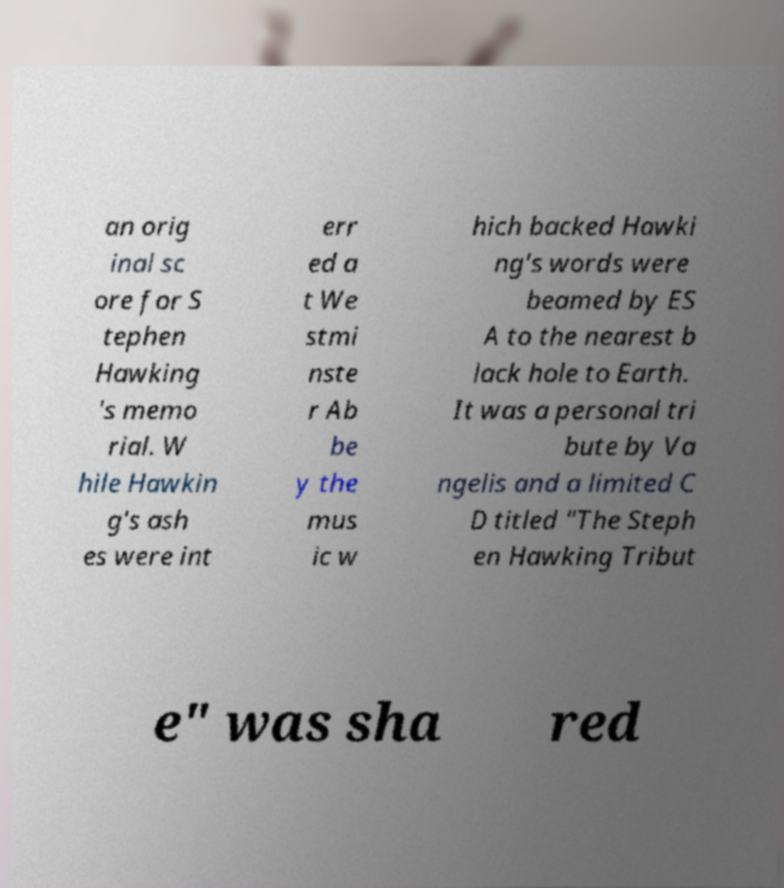Can you read and provide the text displayed in the image?This photo seems to have some interesting text. Can you extract and type it out for me? an orig inal sc ore for S tephen Hawking 's memo rial. W hile Hawkin g's ash es were int err ed a t We stmi nste r Ab be y the mus ic w hich backed Hawki ng's words were beamed by ES A to the nearest b lack hole to Earth. It was a personal tri bute by Va ngelis and a limited C D titled "The Steph en Hawking Tribut e" was sha red 